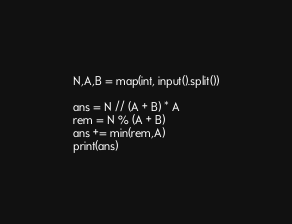Convert code to text. <code><loc_0><loc_0><loc_500><loc_500><_Python_>N,A,B = map(int, input().split())

ans = N // (A + B) * A
rem = N % (A + B)
ans += min(rem,A)
print(ans)</code> 